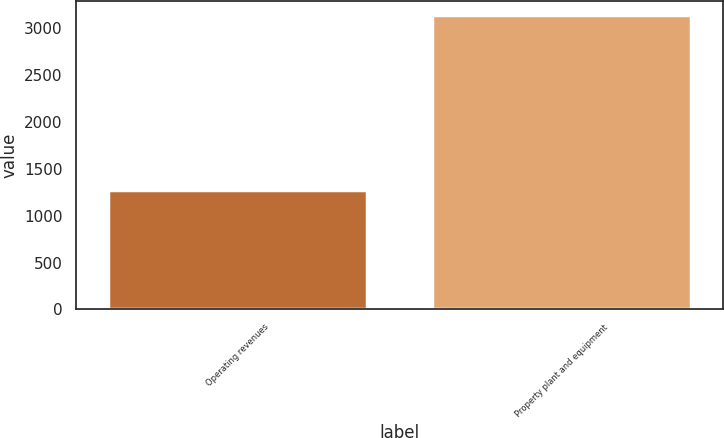<chart> <loc_0><loc_0><loc_500><loc_500><bar_chart><fcel>Operating revenues<fcel>Property plant and equipment<nl><fcel>1271<fcel>3139<nl></chart> 